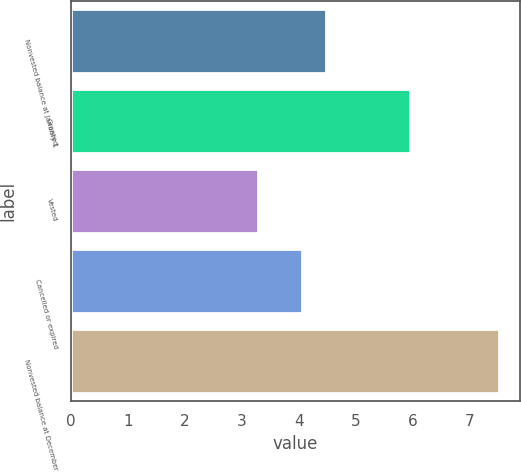Convert chart to OTSL. <chart><loc_0><loc_0><loc_500><loc_500><bar_chart><fcel>Nonvested balance at January 1<fcel>Granted<fcel>Vested<fcel>Cancelled or expired<fcel>Nonvested balance at December<nl><fcel>4.48<fcel>5.96<fcel>3.28<fcel>4.06<fcel>7.52<nl></chart> 